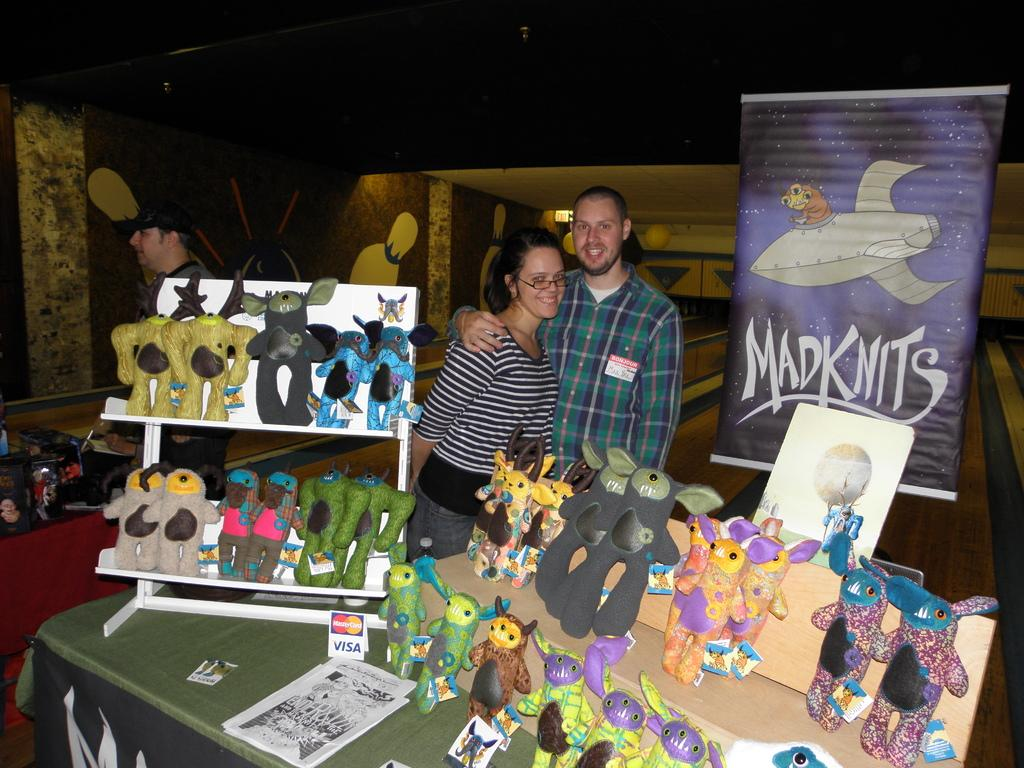How many people are present in the image? There are two persons in the image. What can be seen on the table in the image? There are toys on a table in the image. What type of glass is being used by one of the persons in the image? There is no glass present in the image; it only shows two persons and toys on a table. 